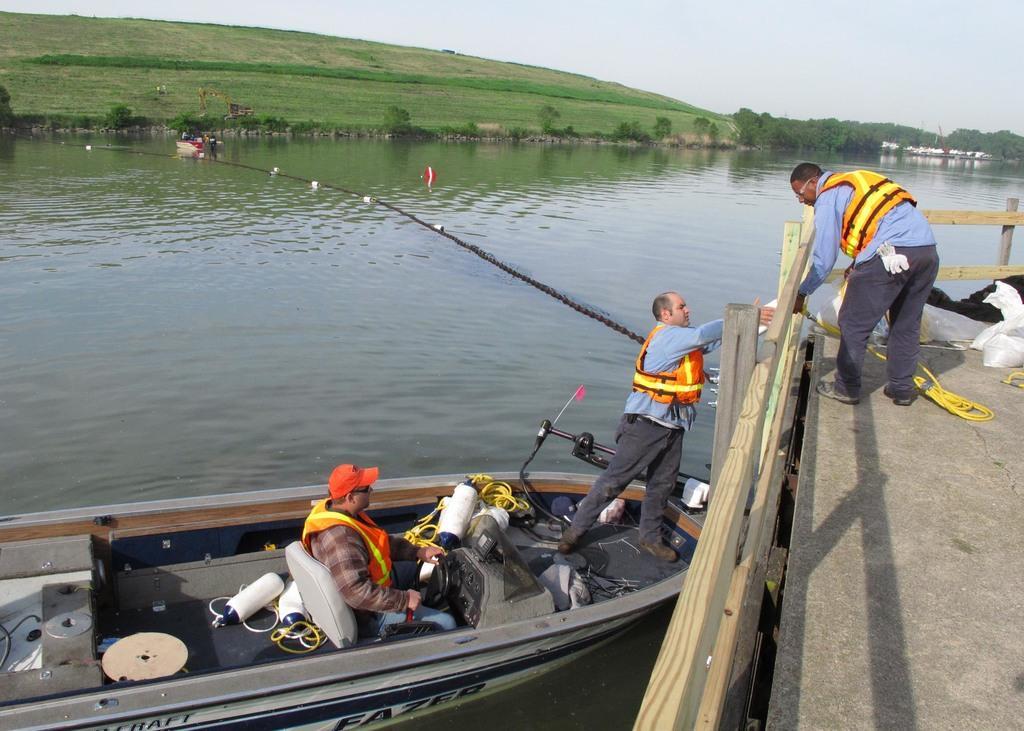In one or two sentences, can you explain what this image depicts? In this picture we can see a boat here, there are two persons in the boat, we can see rope here, on the right side there is a fencing, we can see a person standing here, at the bottom there is water, we can see some grass and trees here, there is sky at the top of the picture. 